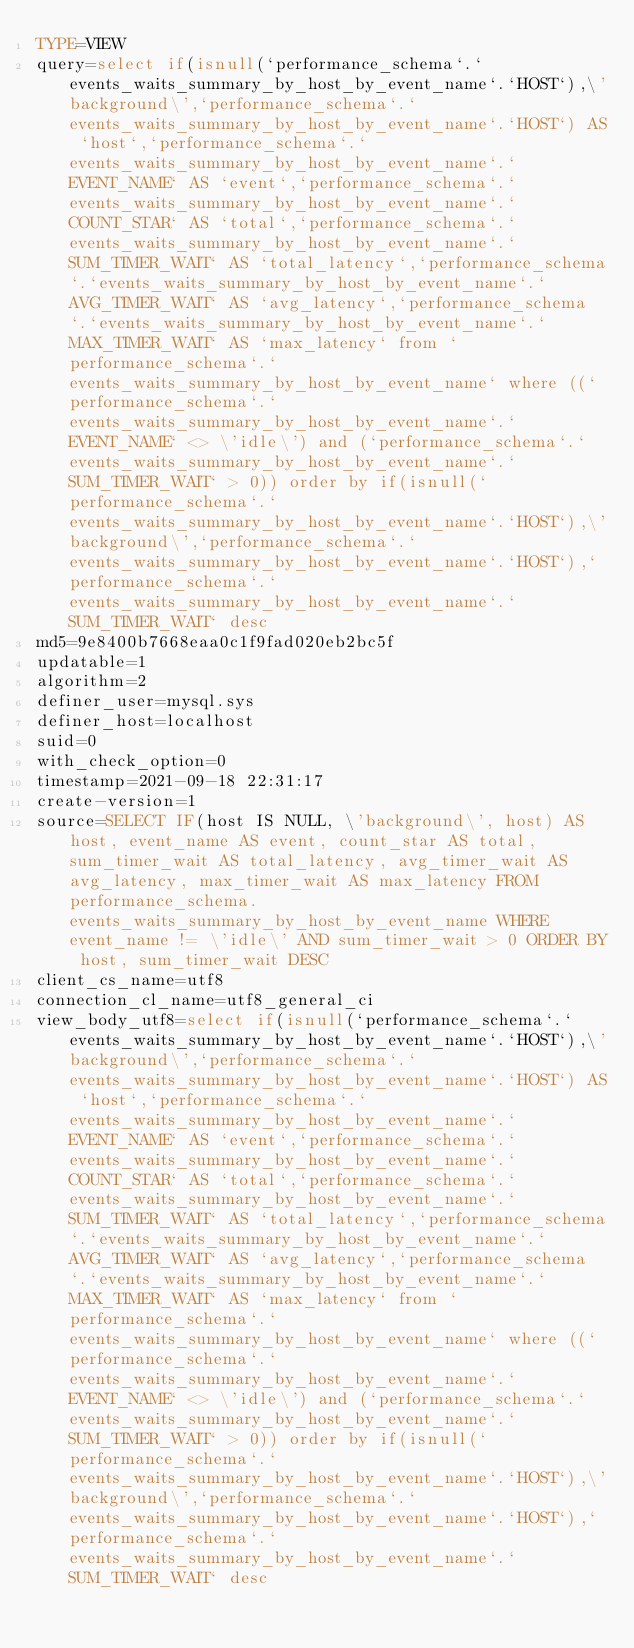Convert code to text. <code><loc_0><loc_0><loc_500><loc_500><_VisualBasic_>TYPE=VIEW
query=select if(isnull(`performance_schema`.`events_waits_summary_by_host_by_event_name`.`HOST`),\'background\',`performance_schema`.`events_waits_summary_by_host_by_event_name`.`HOST`) AS `host`,`performance_schema`.`events_waits_summary_by_host_by_event_name`.`EVENT_NAME` AS `event`,`performance_schema`.`events_waits_summary_by_host_by_event_name`.`COUNT_STAR` AS `total`,`performance_schema`.`events_waits_summary_by_host_by_event_name`.`SUM_TIMER_WAIT` AS `total_latency`,`performance_schema`.`events_waits_summary_by_host_by_event_name`.`AVG_TIMER_WAIT` AS `avg_latency`,`performance_schema`.`events_waits_summary_by_host_by_event_name`.`MAX_TIMER_WAIT` AS `max_latency` from `performance_schema`.`events_waits_summary_by_host_by_event_name` where ((`performance_schema`.`events_waits_summary_by_host_by_event_name`.`EVENT_NAME` <> \'idle\') and (`performance_schema`.`events_waits_summary_by_host_by_event_name`.`SUM_TIMER_WAIT` > 0)) order by if(isnull(`performance_schema`.`events_waits_summary_by_host_by_event_name`.`HOST`),\'background\',`performance_schema`.`events_waits_summary_by_host_by_event_name`.`HOST`),`performance_schema`.`events_waits_summary_by_host_by_event_name`.`SUM_TIMER_WAIT` desc
md5=9e8400b7668eaa0c1f9fad020eb2bc5f
updatable=1
algorithm=2
definer_user=mysql.sys
definer_host=localhost
suid=0
with_check_option=0
timestamp=2021-09-18 22:31:17
create-version=1
source=SELECT IF(host IS NULL, \'background\', host) AS host, event_name AS event, count_star AS total, sum_timer_wait AS total_latency, avg_timer_wait AS avg_latency, max_timer_wait AS max_latency FROM performance_schema.events_waits_summary_by_host_by_event_name WHERE event_name != \'idle\' AND sum_timer_wait > 0 ORDER BY host, sum_timer_wait DESC
client_cs_name=utf8
connection_cl_name=utf8_general_ci
view_body_utf8=select if(isnull(`performance_schema`.`events_waits_summary_by_host_by_event_name`.`HOST`),\'background\',`performance_schema`.`events_waits_summary_by_host_by_event_name`.`HOST`) AS `host`,`performance_schema`.`events_waits_summary_by_host_by_event_name`.`EVENT_NAME` AS `event`,`performance_schema`.`events_waits_summary_by_host_by_event_name`.`COUNT_STAR` AS `total`,`performance_schema`.`events_waits_summary_by_host_by_event_name`.`SUM_TIMER_WAIT` AS `total_latency`,`performance_schema`.`events_waits_summary_by_host_by_event_name`.`AVG_TIMER_WAIT` AS `avg_latency`,`performance_schema`.`events_waits_summary_by_host_by_event_name`.`MAX_TIMER_WAIT` AS `max_latency` from `performance_schema`.`events_waits_summary_by_host_by_event_name` where ((`performance_schema`.`events_waits_summary_by_host_by_event_name`.`EVENT_NAME` <> \'idle\') and (`performance_schema`.`events_waits_summary_by_host_by_event_name`.`SUM_TIMER_WAIT` > 0)) order by if(isnull(`performance_schema`.`events_waits_summary_by_host_by_event_name`.`HOST`),\'background\',`performance_schema`.`events_waits_summary_by_host_by_event_name`.`HOST`),`performance_schema`.`events_waits_summary_by_host_by_event_name`.`SUM_TIMER_WAIT` desc
</code> 